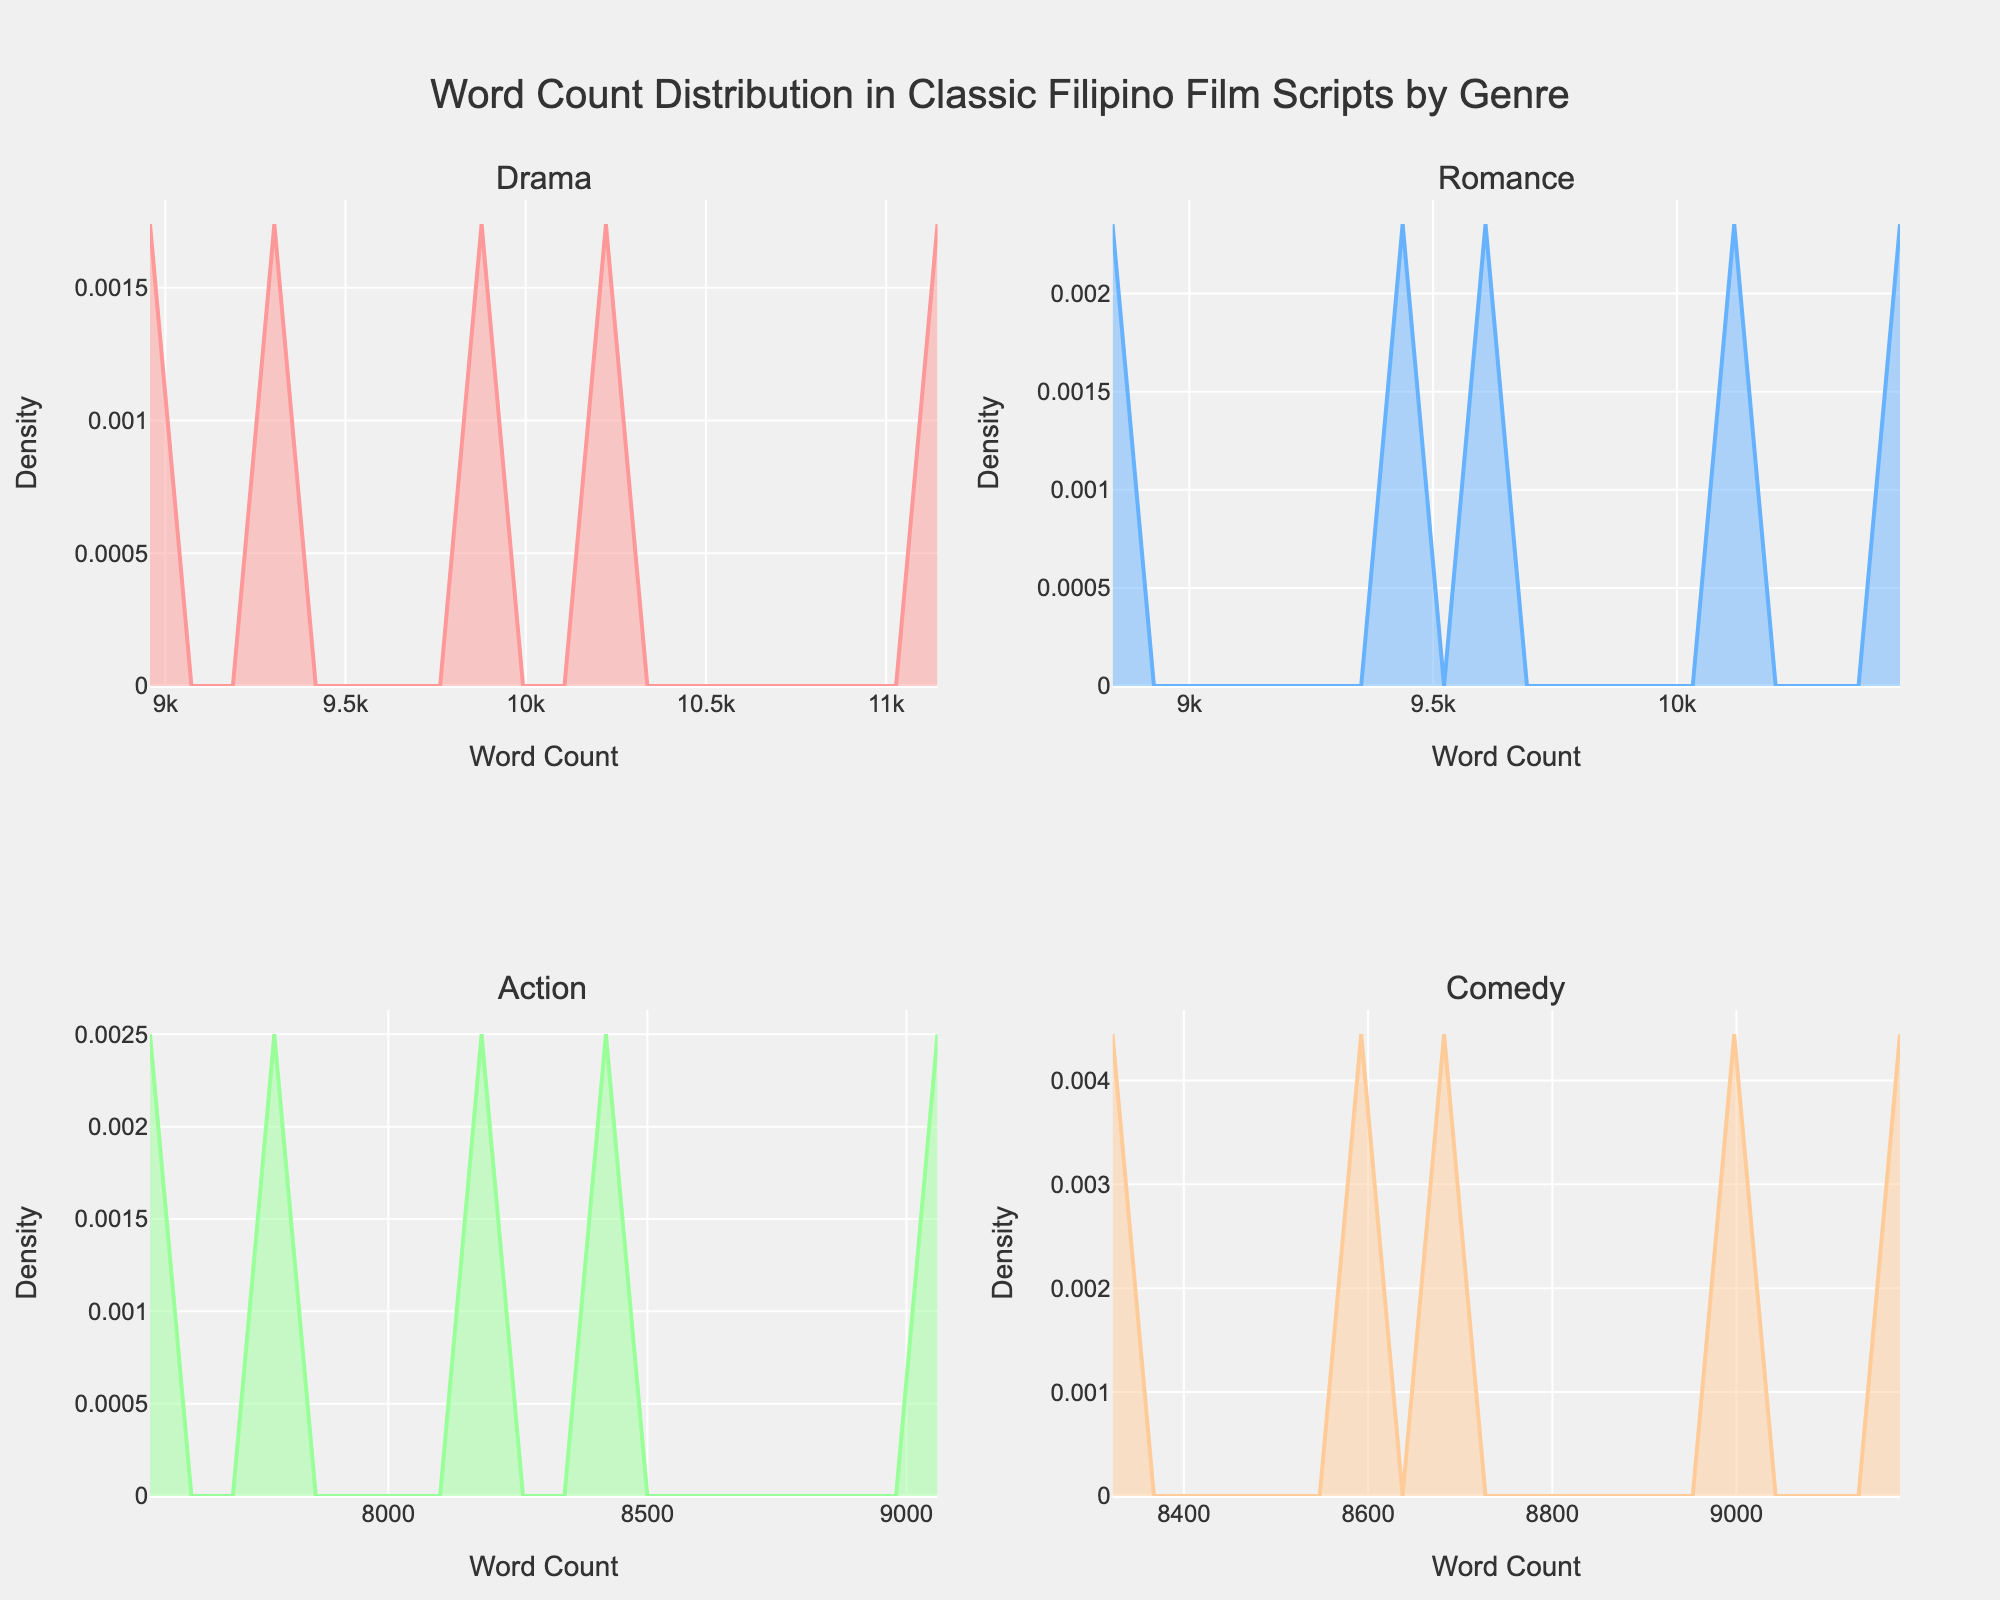What's the highest peak of the density plot for Drama genre? Looking at the subplot for the Drama genre, identify the maximum value on the y-axis. This represents the highest peak of the density plot.
Answer: Around 0.00013 Which genre seems to have the lowest word count density peak? Compare the y-axis peaks of all the subplots. The genre with the lowest peak indicates the lowest word count density.
Answer: Action How do the peaks of Drama and Romance density plots compare? Observe the height of the peaks in the Drama and Romance subplots. Compare the maximum values on the y-axis for these genres.
Answer: Drama peaks higher Among the four genres, which one has the widest range of word count distribution? Look at the x-axis spanning each subplot to determine which genre has the most spread-out distribution.
Answer: Romance What is the title of the plot? The title of the plot is typically found at the top center of the figure.
Answer: Word Count Distribution in Classic Filipino Film Scripts by Genre What's the word count range with the highest density for Action films? In the subplot for Action films, find the x-axis range under the highest peak of the density plot.
Answer: 7500-8500 Are there any genres whose density plots overlap significantly in their word count distributions? Evaluate if any two subplots share similar x-axis ranges and height patterns, indicating overlapping word count distributions.
Answer: No significant overlap Which density plot has the sharpest peak? Determine the subplot where the density plot has the narrowest and highest peak on the y-axis.
Answer: Drama What is the color used for the Comedy genre's density plot? Identify the color used in the subplot for the Comedy genre by visual inspection.
Answer: Light Orange Is the density plot for the Action genre more skewed towards lower or higher word counts? Examine the shape of the density plot for the Action genre to see where the major density lies.
Answer: Lower word counts 